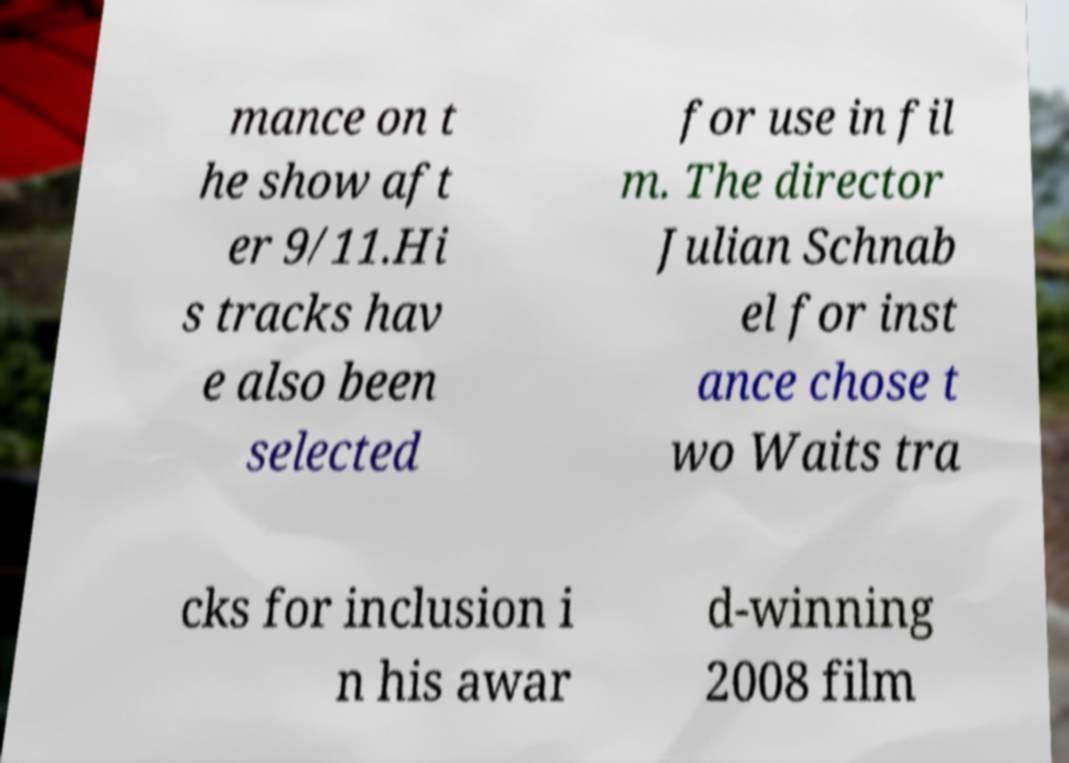Could you assist in decoding the text presented in this image and type it out clearly? mance on t he show aft er 9/11.Hi s tracks hav e also been selected for use in fil m. The director Julian Schnab el for inst ance chose t wo Waits tra cks for inclusion i n his awar d-winning 2008 film 